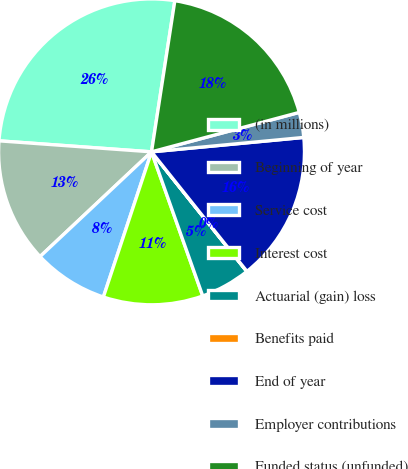Convert chart. <chart><loc_0><loc_0><loc_500><loc_500><pie_chart><fcel>(in millions)<fcel>Beginning of year<fcel>Service cost<fcel>Interest cost<fcel>Actuarial (gain) loss<fcel>Benefits paid<fcel>End of year<fcel>Employer contributions<fcel>Funded status (unfunded)<nl><fcel>26.29%<fcel>13.15%<fcel>7.9%<fcel>10.53%<fcel>5.27%<fcel>0.02%<fcel>15.78%<fcel>2.65%<fcel>18.41%<nl></chart> 